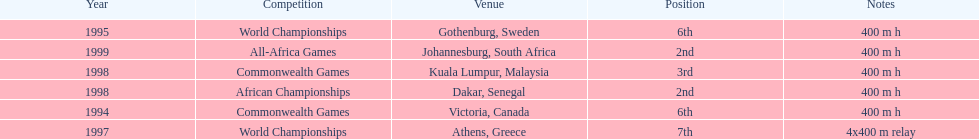Other than 1999, what year did ken harnden win second place? 1998. 